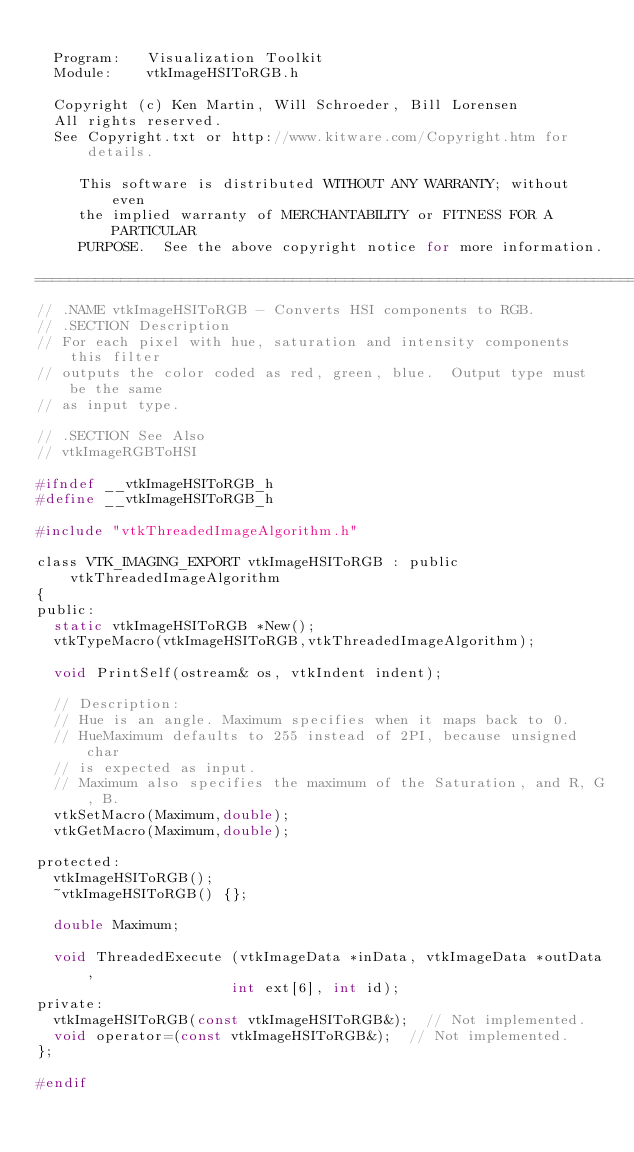<code> <loc_0><loc_0><loc_500><loc_500><_C_>
  Program:   Visualization Toolkit
  Module:    vtkImageHSIToRGB.h

  Copyright (c) Ken Martin, Will Schroeder, Bill Lorensen
  All rights reserved.
  See Copyright.txt or http://www.kitware.com/Copyright.htm for details.

     This software is distributed WITHOUT ANY WARRANTY; without even
     the implied warranty of MERCHANTABILITY or FITNESS FOR A PARTICULAR
     PURPOSE.  See the above copyright notice for more information.

=========================================================================*/
// .NAME vtkImageHSIToRGB - Converts HSI components to RGB.
// .SECTION Description
// For each pixel with hue, saturation and intensity components this filter
// outputs the color coded as red, green, blue.  Output type must be the same
// as input type.

// .SECTION See Also
// vtkImageRGBToHSI

#ifndef __vtkImageHSIToRGB_h
#define __vtkImageHSIToRGB_h

#include "vtkThreadedImageAlgorithm.h"

class VTK_IMAGING_EXPORT vtkImageHSIToRGB : public vtkThreadedImageAlgorithm
{
public:
  static vtkImageHSIToRGB *New();
  vtkTypeMacro(vtkImageHSIToRGB,vtkThreadedImageAlgorithm);

  void PrintSelf(ostream& os, vtkIndent indent);

  // Description:
  // Hue is an angle. Maximum specifies when it maps back to 0.
  // HueMaximum defaults to 255 instead of 2PI, because unsigned char
  // is expected as input.
  // Maximum also specifies the maximum of the Saturation, and R, G, B.
  vtkSetMacro(Maximum,double);
  vtkGetMacro(Maximum,double);
  
protected:
  vtkImageHSIToRGB();
  ~vtkImageHSIToRGB() {};

  double Maximum;
  
  void ThreadedExecute (vtkImageData *inData, vtkImageData *outData,
                       int ext[6], int id);
private:
  vtkImageHSIToRGB(const vtkImageHSIToRGB&);  // Not implemented.
  void operator=(const vtkImageHSIToRGB&);  // Not implemented.
};

#endif



</code> 